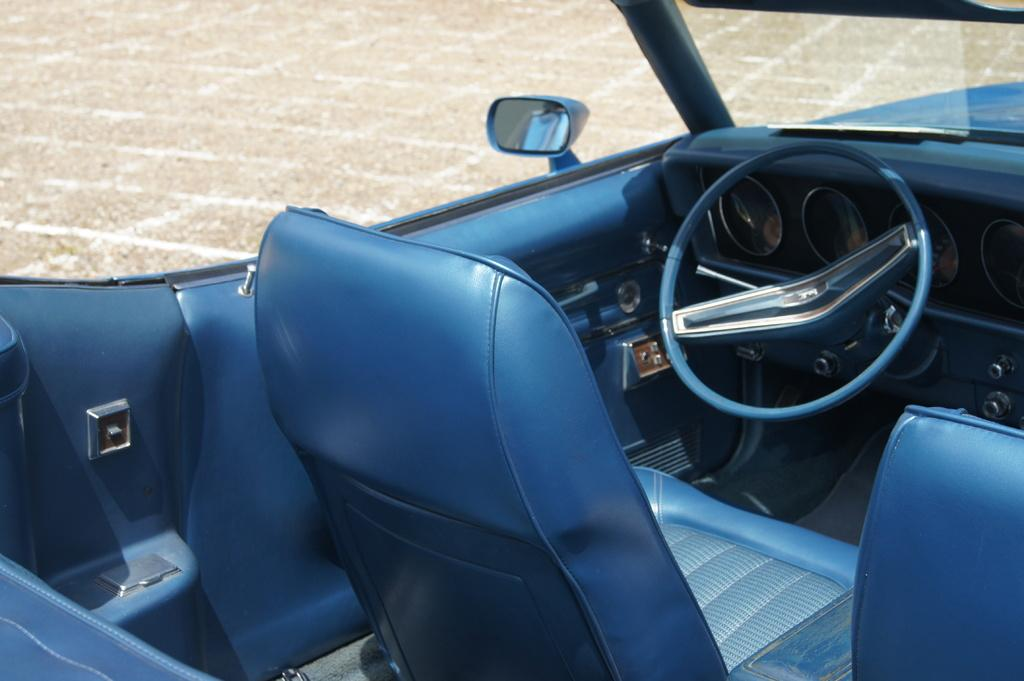What type of object is present in the image that typically has seats and a steering wheel? The image contains a car, which typically has seats and a steering wheel. Can you describe the background of the image? There is ground visible in the background of the image. What type of work is being done in space in the image? There is no reference to work or space in the image; it contains a car with seats and a steering wheel, and a ground background. 